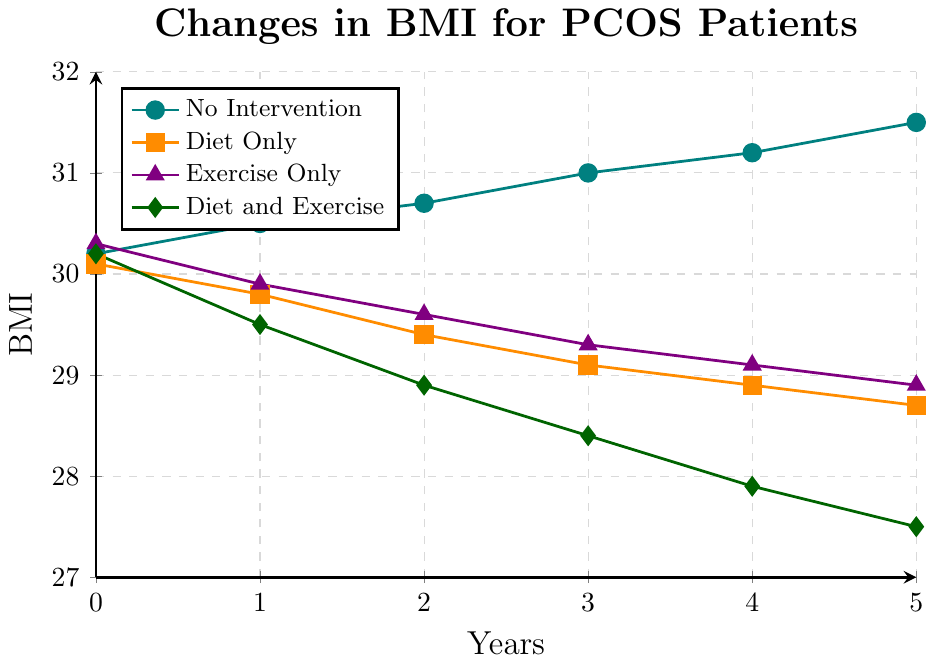What is the trend in BMI for PCOS patients with no intervention over the 5-year period? The BMI for patients with no intervention steadily increases over the 5-year period. Starting from 30.2, it increases each year and reaches 31.5 at the end of the period.
Answer: Steadily increasing Which group shows the greatest decrease in BMI over the 5-year period? Comparing the differences in BMI from year 0 to year 5 for each group: No Intervention (31.5 - 30.2 = +1.3), Diet Only (30.1 - 28.7 = -1.4), Exercise Only (30.3 - 28.9 = -1.4), and Diet and Exercise (30.2 - 27.5 = -2.7). The Diet and Exercise group shows the greatest decrease in BMI.
Answer: Diet and Exercise What is the BMI difference between the "No Intervention" group and the "Diet and Exercise" group at the end of the 5-year period? At year 5, BMI for No Intervention is 31.5 and for Diet and Exercise is 27.5. The difference is 31.5 - 27.5 = 4.0.
Answer: 4.0 Which intervention shows a consistent decrease in BMI every year? The Diet and Exercise intervention shows a consistent decrease in BMI every year, starting from 30.2 and decreasing to 27.5 every successive year.
Answer: Diet and Exercise By how much did the BMI of the "Diet Only" group decrease after the first year? At year 0, BMI for Diet Only is 30.1. After the first year, it is 29.8. The decrease is 30.1 - 29.8 = 0.3.
Answer: 0.3 What is the difference in BMI between the "Exercise Only" group and the "Diet Only" group at year 3? At year 3, BMI for Exercise Only is 29.3 and for Diet Only is 29.1. The difference is 29.3 - 29.1 = 0.2.
Answer: 0.2 At what year does the BMI for "No Intervention" group cross 31? The BMI for "No Intervention" crosses 31 at year 3, as it reaches 31.0 that year.
Answer: Year 3 Which intervention group had the lowest BMI at any point during the 5-year period? At year 5, the Diet and Exercise group has the lowest BMI at 27.5, which is lower than any BMI value recorded for any other group during the period.
Answer: Diet and Exercise What is the total change in BMI for the "Exercise Only" group from year 0 to year 5? The BMI for the Exercise Only group at year 0 is 30.3 and at year 5 is 28.9. The total change is 30.3 - 28.9 = 1.4.
Answer: -1.4 How does the trend of "Diet Only" compare to "Exercise Only" in terms of BMI reduction over the 5-year period? Both groups show a decreasing trend in BMI over the 5-year period. However, the "Diet Only" group reduces more significantly from 30.1 to 28.7, whereas the "Exercise Only" group reduces from 30.3 to 28.9.
Answer: Diet Only reduces more 